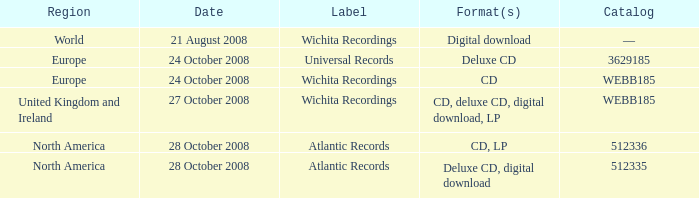Which date was associated with the release in Europe on the Wichita Recordings label? 24 October 2008. Parse the full table. {'header': ['Region', 'Date', 'Label', 'Format(s)', 'Catalog'], 'rows': [['World', '21 August 2008', 'Wichita Recordings', 'Digital download', '—'], ['Europe', '24 October 2008', 'Universal Records', 'Deluxe CD', '3629185'], ['Europe', '24 October 2008', 'Wichita Recordings', 'CD', 'WEBB185'], ['United Kingdom and Ireland', '27 October 2008', 'Wichita Recordings', 'CD, deluxe CD, digital download, LP', 'WEBB185'], ['North America', '28 October 2008', 'Atlantic Records', 'CD, LP', '512336'], ['North America', '28 October 2008', 'Atlantic Records', 'Deluxe CD, digital download', '512335']]} 